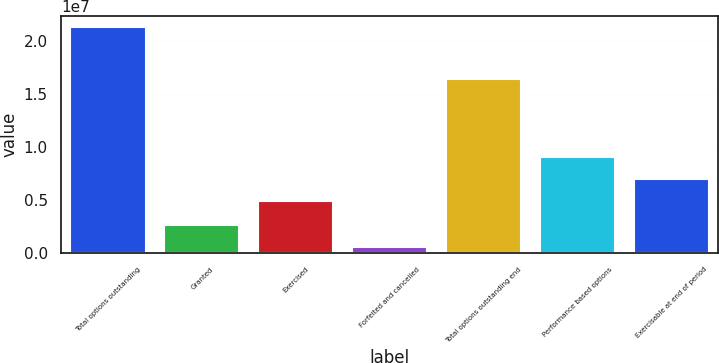Convert chart. <chart><loc_0><loc_0><loc_500><loc_500><bar_chart><fcel>Total options outstanding<fcel>Granted<fcel>Exercised<fcel>Forfeited and cancelled<fcel>Total options outstanding end<fcel>Performance based options<fcel>Exercisable at end of period<nl><fcel>2.13362e+07<fcel>2.66227e+06<fcel>4.94039e+06<fcel>587396<fcel>1.63999e+07<fcel>9.09015e+06<fcel>7.01527e+06<nl></chart> 